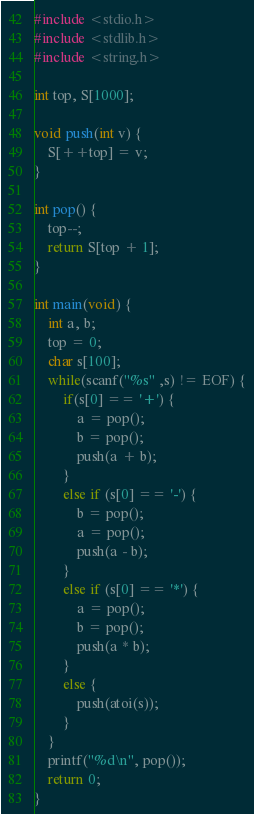<code> <loc_0><loc_0><loc_500><loc_500><_C++_>#include <stdio.h>
#include <stdlib.h>
#include <string.h>

int top, S[1000];

void push(int v) {
    S[++top] = v;   
}

int pop() {
    top--;
    return S[top + 1];
}

int main(void) {
    int a, b;
    top = 0;
    char s[100];
    while(scanf("%s" ,s) != EOF) {
        if(s[0] == '+') {
            a = pop();
            b = pop();
            push(a + b);
        }
        else if (s[0] == '-') {
            b = pop();
            a = pop();
            push(a - b);
        }
        else if (s[0] == '*') {
            a = pop();
            b = pop();
            push(a * b);
        }
        else {
            push(atoi(s));
        }
    }
    printf("%d\n", pop());
    return 0;
}
</code> 